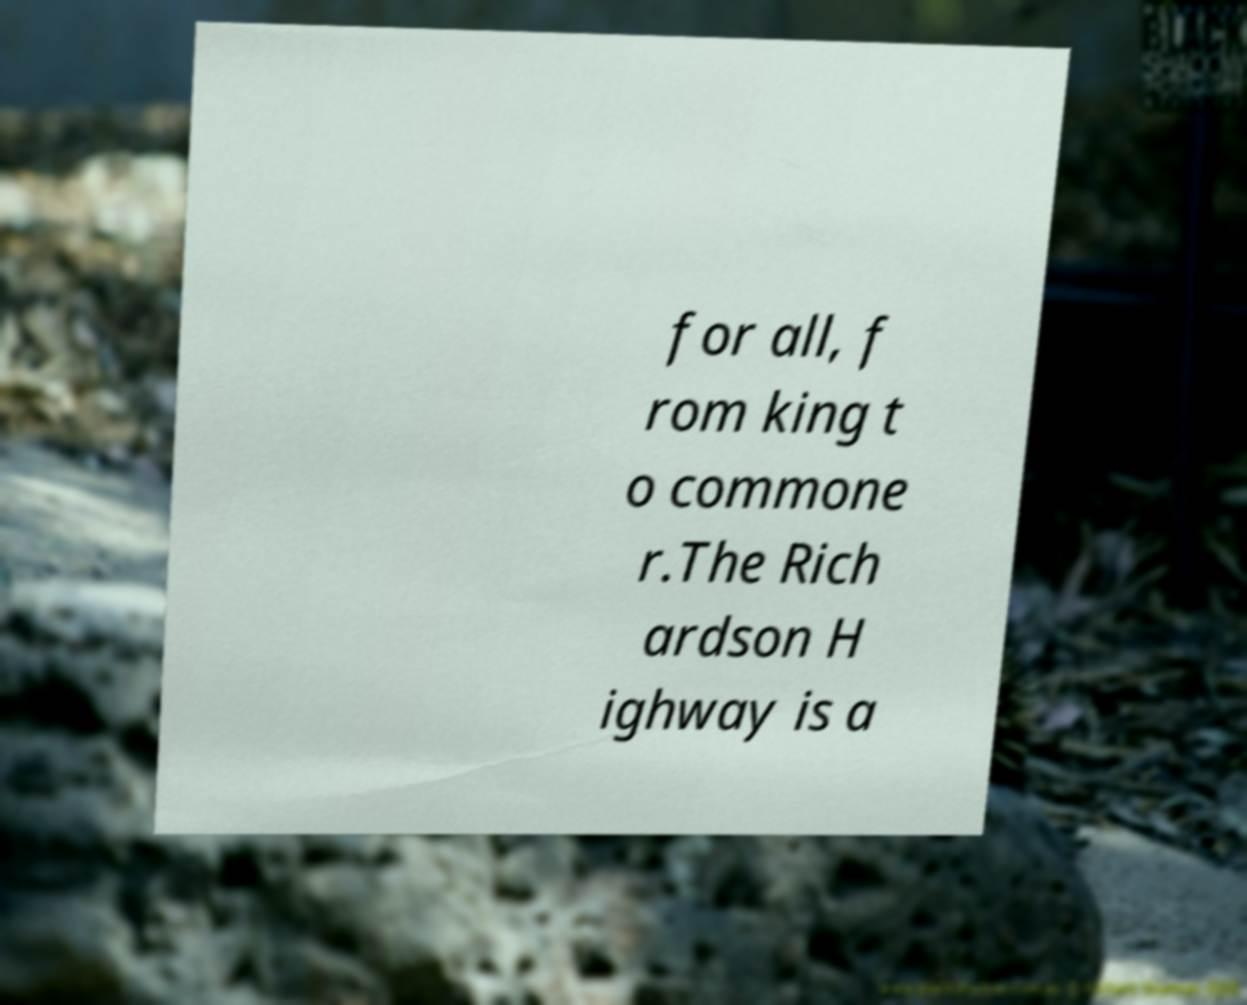Can you read and provide the text displayed in the image?This photo seems to have some interesting text. Can you extract and type it out for me? for all, f rom king t o commone r.The Rich ardson H ighway is a 